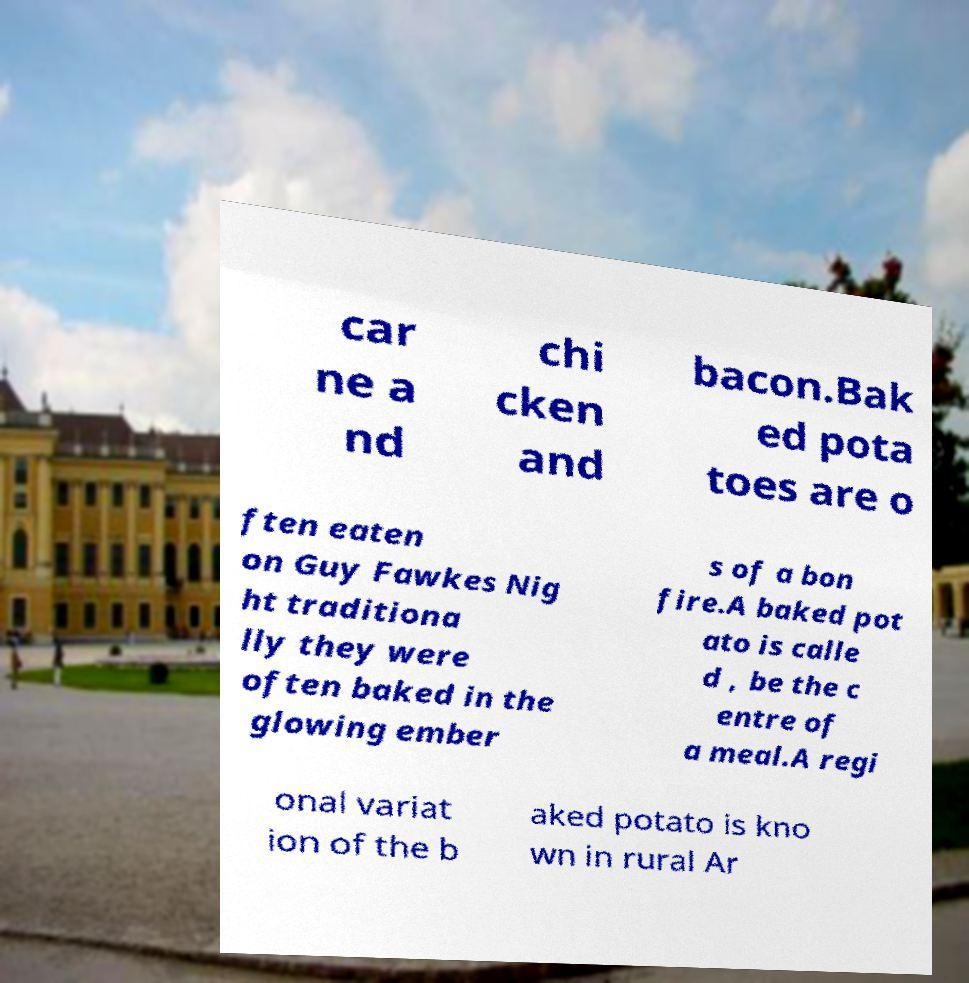What messages or text are displayed in this image? I need them in a readable, typed format. car ne a nd chi cken and bacon.Bak ed pota toes are o ften eaten on Guy Fawkes Nig ht traditiona lly they were often baked in the glowing ember s of a bon fire.A baked pot ato is calle d , be the c entre of a meal.A regi onal variat ion of the b aked potato is kno wn in rural Ar 